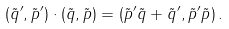Convert formula to latex. <formula><loc_0><loc_0><loc_500><loc_500>( \tilde { q } ^ { \prime } , \tilde { p } ^ { \prime } ) \cdot ( \tilde { q } , \tilde { p } ) = ( \tilde { p } ^ { \prime } \tilde { q } + \tilde { q } ^ { \prime } , \tilde { p } ^ { \prime } \tilde { p } ) \, .</formula> 